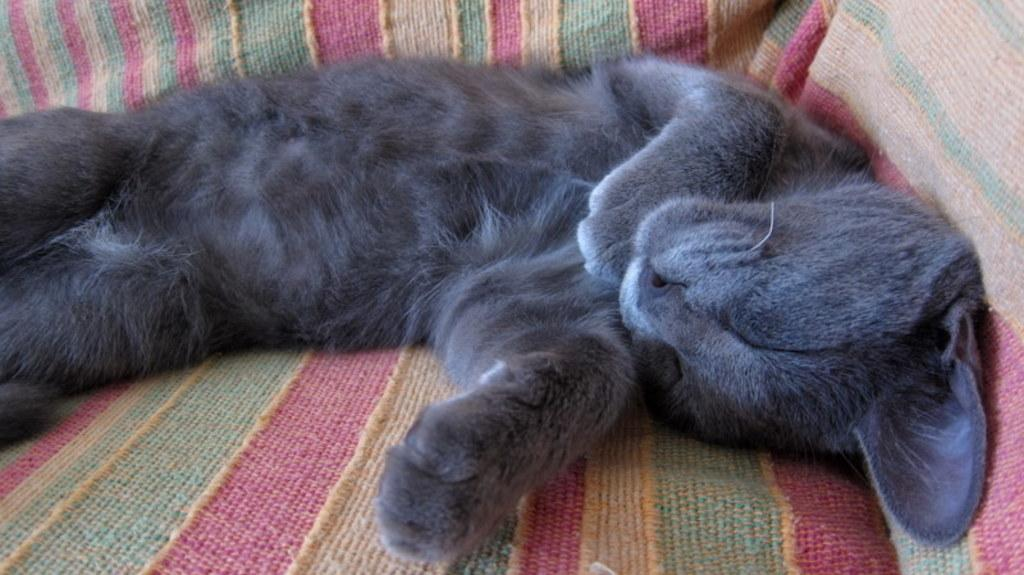What type of animal is in the image? There is a gray color cat in the image. What is the cat doing in the image? The cat is lying on a sofa. What type of yam is being used as a pillow for the cat in the image? There is no yam present in the image; the cat is lying on a sofa. Who is the owner of the cat in the image? The image does not provide information about the cat's owner. 